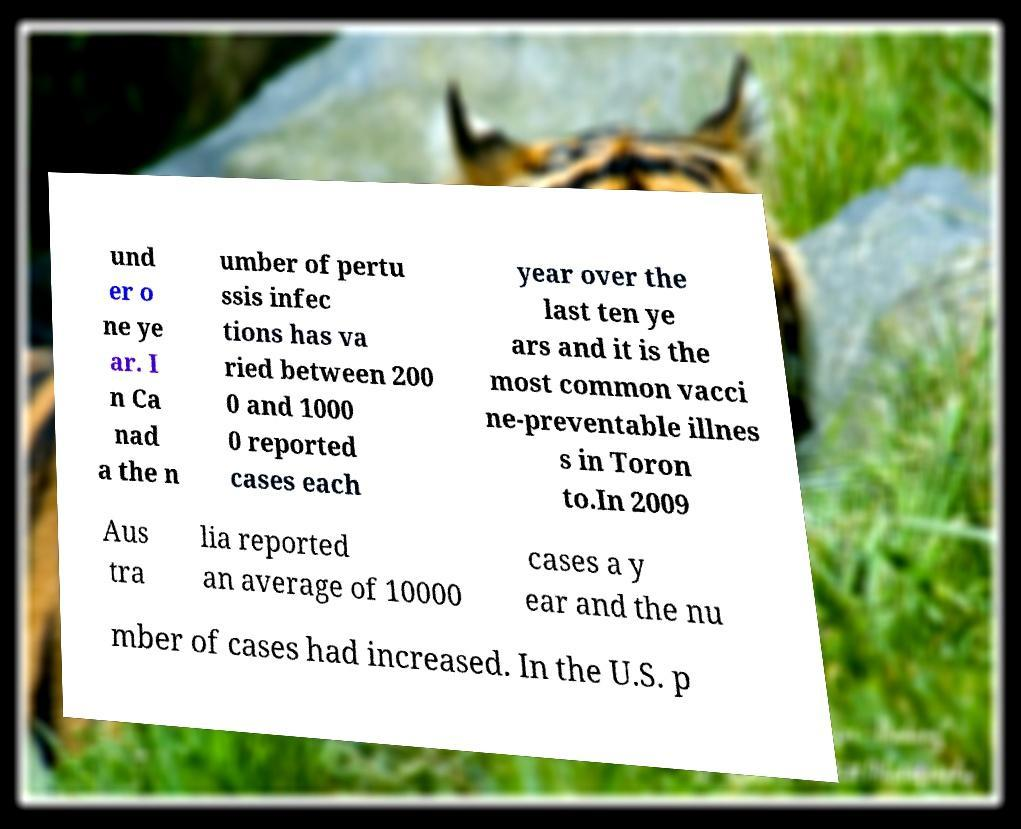Can you read and provide the text displayed in the image?This photo seems to have some interesting text. Can you extract and type it out for me? und er o ne ye ar. I n Ca nad a the n umber of pertu ssis infec tions has va ried between 200 0 and 1000 0 reported cases each year over the last ten ye ars and it is the most common vacci ne-preventable illnes s in Toron to.In 2009 Aus tra lia reported an average of 10000 cases a y ear and the nu mber of cases had increased. In the U.S. p 